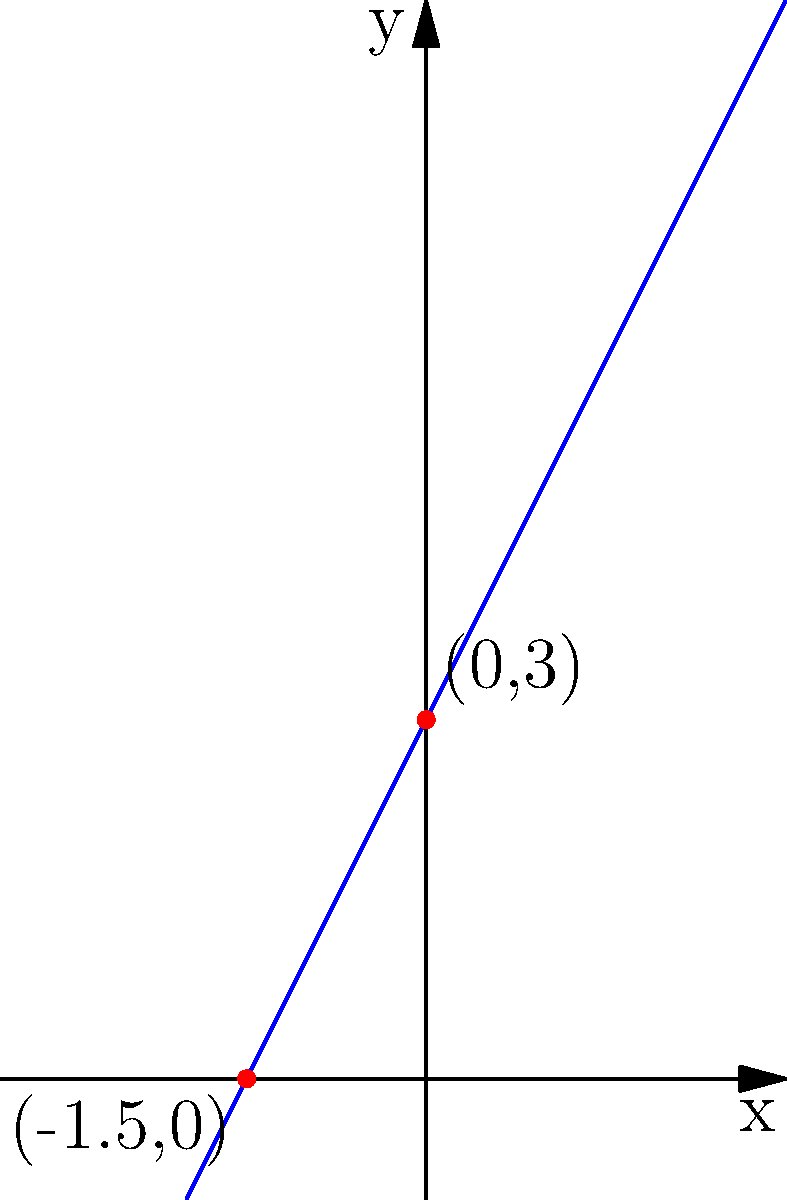In our village, we use lines to represent the boundaries of farmlands. Consider a line that passes through two points: one at the village center (0,3) and another at the elder's hut (-1.5,0). What is the equation of this line, and how does it relate to our ancestral land division practices? To find the equation of the line, we'll follow these steps:

1. Calculate the slope (m):
   The slope represents how steep our land boundary is.
   $$m = \frac{y_2 - y_1}{x_2 - x_1} = \frac{0 - 3}{-1.5 - 0} = \frac{-3}{-1.5} = 2$$

2. Use the point-slope form of a line:
   $$y - y_1 = m(x - x_1)$$
   Using the point (0,3):
   $$y - 3 = 2(x - 0)$$

3. Simplify to slope-intercept form:
   $$y - 3 = 2x$$
   $$y = 2x + 3$$

4. Interpret the results:
   - The slope (2) represents how quickly the boundary rises as we move to the right.
   - The y-intercept (3) shows where the boundary crosses the central north-south path.

This equation, $y = 2x + 3$, embodies our ancestral wisdom:
- The slope (2) symbolizes the balance between land and people.
- The y-intercept (3) represents the communal area at the village center.

By understanding this equation, we preserve our traditional land division methods while adapting to modern surveying techniques.
Answer: $y = 2x + 3$ 